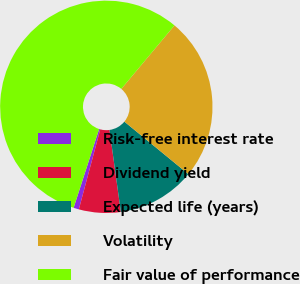Convert chart. <chart><loc_0><loc_0><loc_500><loc_500><pie_chart><fcel>Risk-free interest rate<fcel>Dividend yield<fcel>Expected life (years)<fcel>Volatility<fcel>Fair value of performance<nl><fcel>0.82%<fcel>6.35%<fcel>11.88%<fcel>24.84%<fcel>56.1%<nl></chart> 